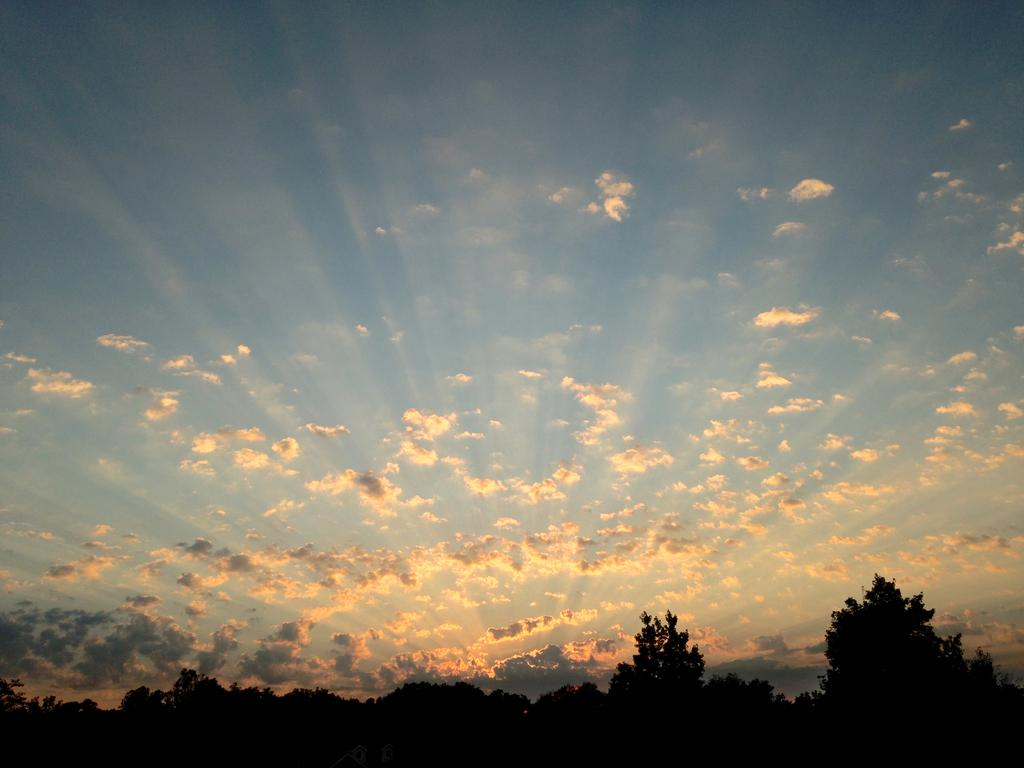What type of vegetation can be seen in the image? There are trees in the image. What is visible in the background of the image? The sky is visible in the background of the image. What can be observed in the sky? Clouds are present in the sky. What type of office furniture can be seen in the image? There is no office furniture present in the image; it features trees and a sky with clouds. Can you hear the voice of the scarecrow in the image? There is no scarecrow present in the image, so it is not possible to hear its voice. 